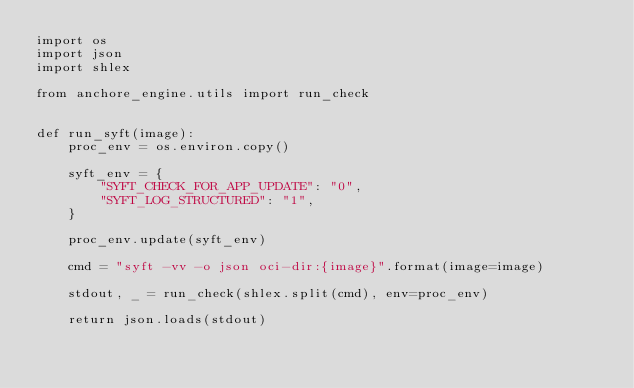<code> <loc_0><loc_0><loc_500><loc_500><_Python_>import os
import json
import shlex

from anchore_engine.utils import run_check


def run_syft(image):
    proc_env = os.environ.copy()

    syft_env = {
        "SYFT_CHECK_FOR_APP_UPDATE": "0",
        "SYFT_LOG_STRUCTURED": "1",
    }

    proc_env.update(syft_env)

    cmd = "syft -vv -o json oci-dir:{image}".format(image=image)

    stdout, _ = run_check(shlex.split(cmd), env=proc_env)

    return json.loads(stdout)
</code> 